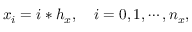Convert formula to latex. <formula><loc_0><loc_0><loc_500><loc_500>x _ { i } = i * h _ { x } , \quad i = 0 , 1 , \cdots , n _ { x } ,</formula> 